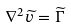Convert formula to latex. <formula><loc_0><loc_0><loc_500><loc_500>\nabla ^ { 2 } \widetilde { v } = \widetilde { \Gamma }</formula> 